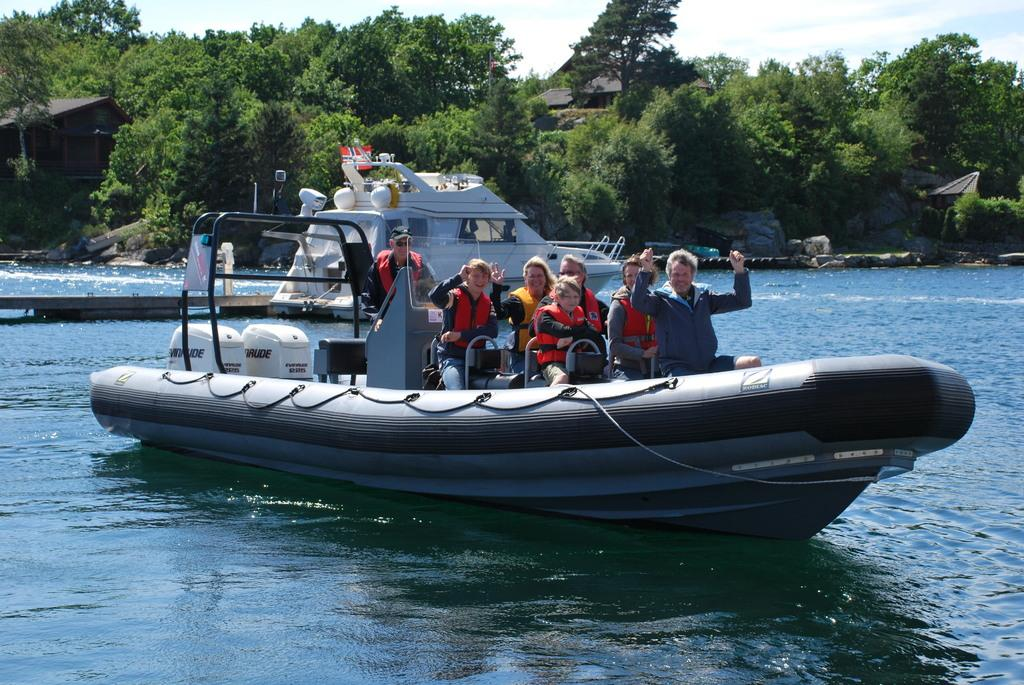What is the main subject in the center of the image? There is a boat in the center of the image. Where is the boat located? The boat is on the water. Who or what is inside the boat? There are people in the boat. What can be seen in the background of the image? There are trees and sheds in the background of the image. What is visible at the top of the image? The sky is visible at the top of the image. What type of apple is being used as a paddle in the image? There is no apple or paddle present in the image; it features a boat with people on the water. Is there a rainstorm occurring in the image? No, there is no rainstorm depicted in the image; the sky is visible at the top of the image, but no rain or storm clouds are present. 